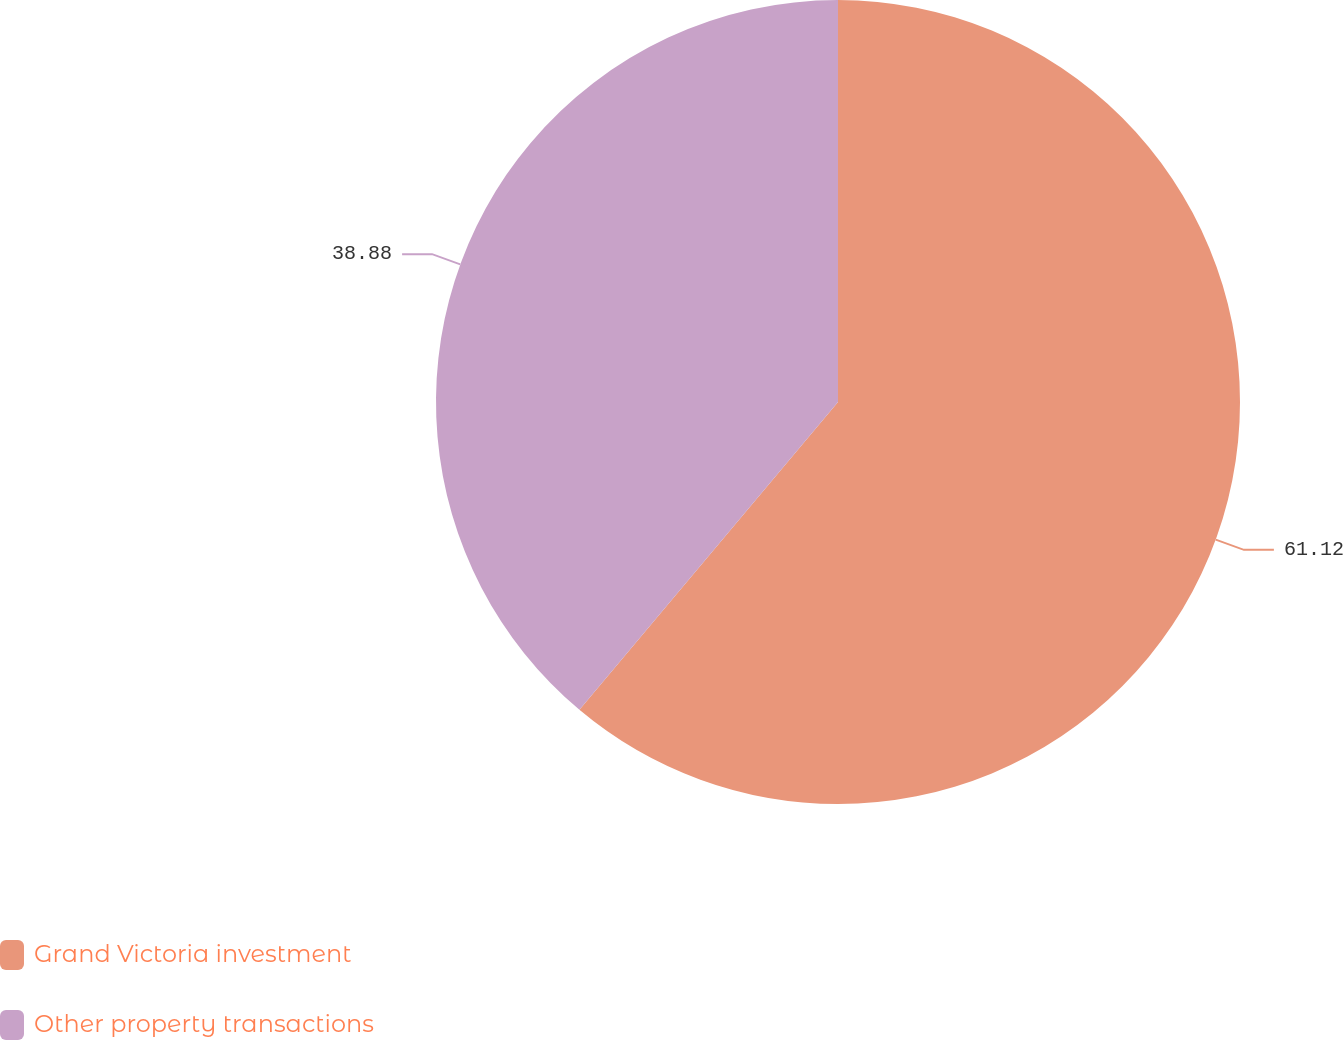<chart> <loc_0><loc_0><loc_500><loc_500><pie_chart><fcel>Grand Victoria investment<fcel>Other property transactions<nl><fcel>61.12%<fcel>38.88%<nl></chart> 